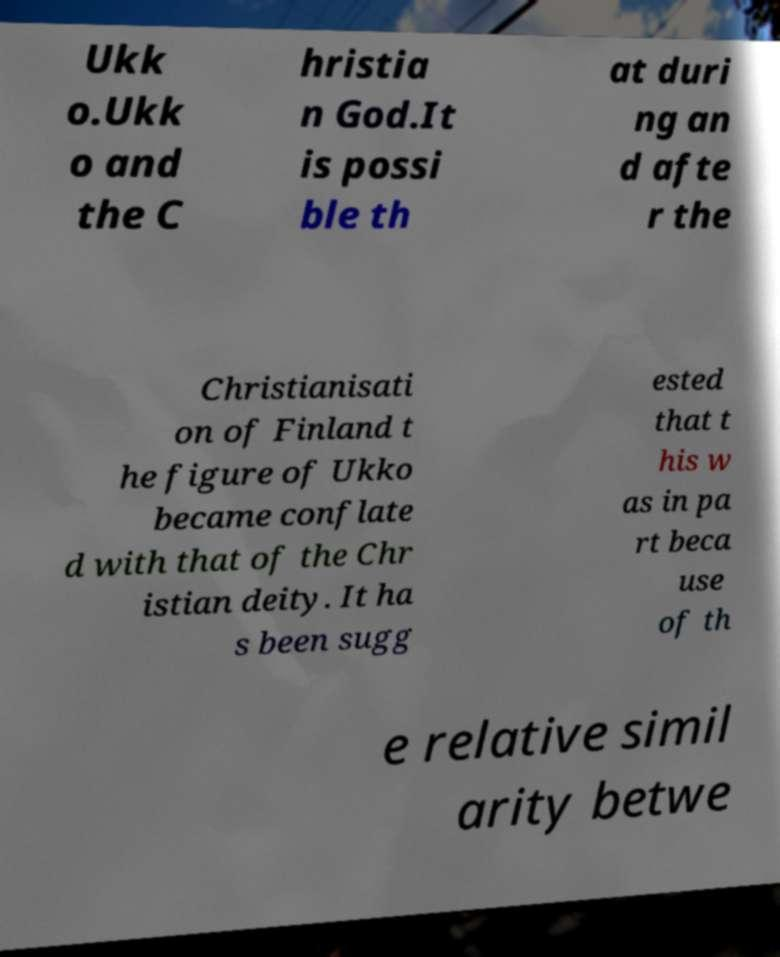Please identify and transcribe the text found in this image. Ukk o.Ukk o and the C hristia n God.It is possi ble th at duri ng an d afte r the Christianisati on of Finland t he figure of Ukko became conflate d with that of the Chr istian deity. It ha s been sugg ested that t his w as in pa rt beca use of th e relative simil arity betwe 